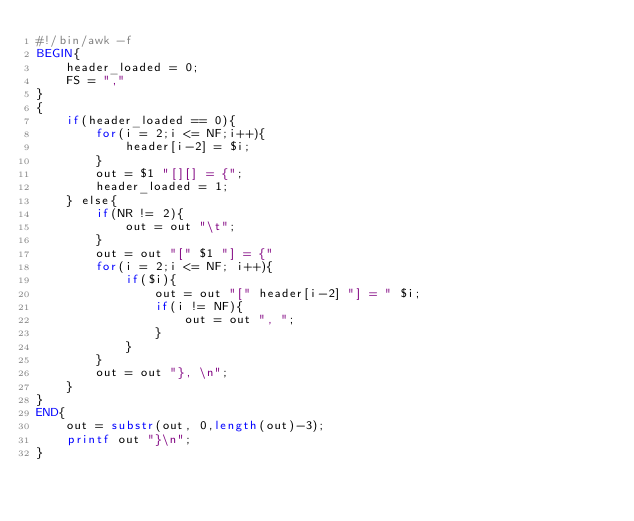Convert code to text. <code><loc_0><loc_0><loc_500><loc_500><_Awk_>#!/bin/awk -f
BEGIN{
	header_loaded = 0;
	FS = ","
}
{
	if(header_loaded == 0){
		for(i = 2;i <= NF;i++){
			header[i-2] = $i;
		}
		out = $1 "[][] = {";
		header_loaded = 1;
	} else{
		if(NR != 2){
			out = out "\t"; 
		}
		out = out "[" $1 "] = {"
		for(i = 2;i <= NF; i++){
			if($i){
				out = out "[" header[i-2] "] = " $i; 
				if(i != NF){
					out = out ", ";
				}
			}
		}	
		out = out "}, \n";
	}	
}
END{
	out = substr(out, 0,length(out)-3);
	printf out "}\n";
}
</code> 